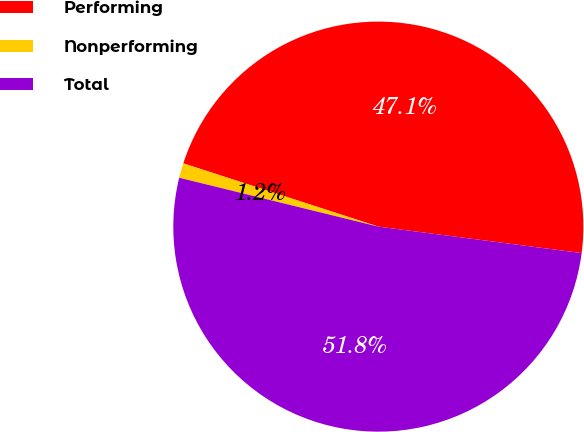<chart> <loc_0><loc_0><loc_500><loc_500><pie_chart><fcel>Performing<fcel>Nonperforming<fcel>Total<nl><fcel>47.07%<fcel>1.16%<fcel>51.77%<nl></chart> 